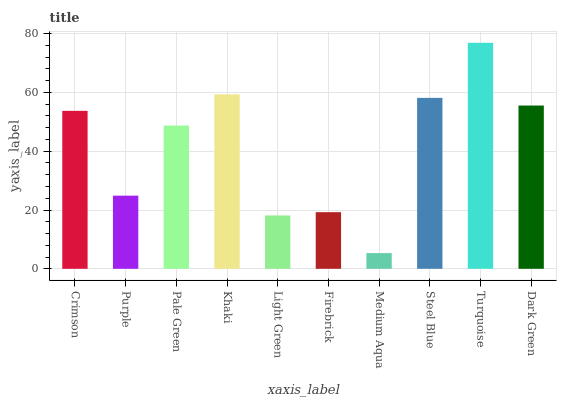Is Medium Aqua the minimum?
Answer yes or no. Yes. Is Turquoise the maximum?
Answer yes or no. Yes. Is Purple the minimum?
Answer yes or no. No. Is Purple the maximum?
Answer yes or no. No. Is Crimson greater than Purple?
Answer yes or no. Yes. Is Purple less than Crimson?
Answer yes or no. Yes. Is Purple greater than Crimson?
Answer yes or no. No. Is Crimson less than Purple?
Answer yes or no. No. Is Crimson the high median?
Answer yes or no. Yes. Is Pale Green the low median?
Answer yes or no. Yes. Is Medium Aqua the high median?
Answer yes or no. No. Is Dark Green the low median?
Answer yes or no. No. 